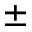<formula> <loc_0><loc_0><loc_500><loc_500>\pm</formula> 